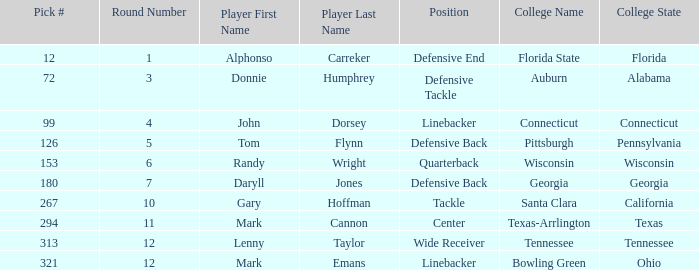In which draft round was a player from the college of connecticut picked? Round 4. 